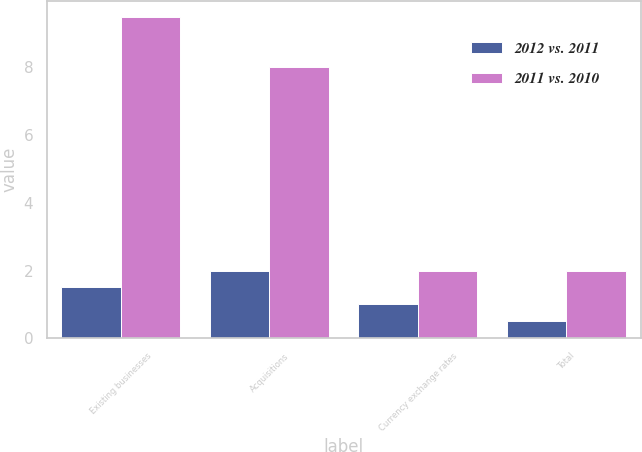Convert chart to OTSL. <chart><loc_0><loc_0><loc_500><loc_500><stacked_bar_chart><ecel><fcel>Existing businesses<fcel>Acquisitions<fcel>Currency exchange rates<fcel>Total<nl><fcel>2012 vs. 2011<fcel>1.5<fcel>2<fcel>1<fcel>0.5<nl><fcel>2011 vs. 2010<fcel>9.5<fcel>8<fcel>2<fcel>2<nl></chart> 